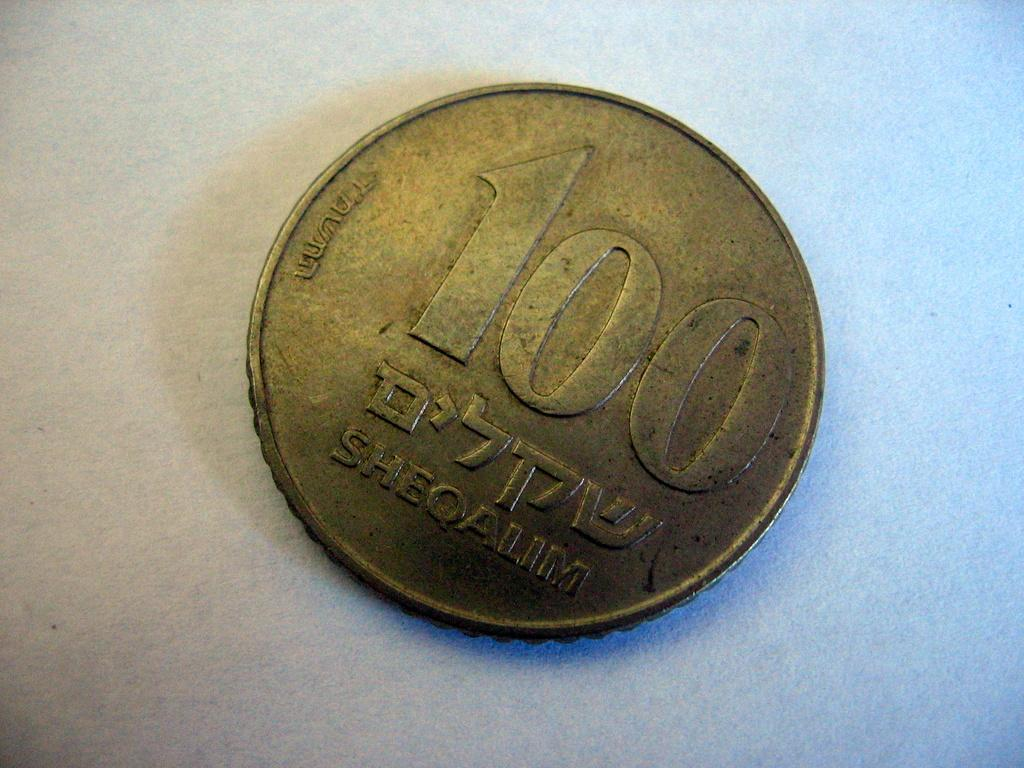<image>
Write a terse but informative summary of the picture. a 100 Sheoalim bronze coin on white background 